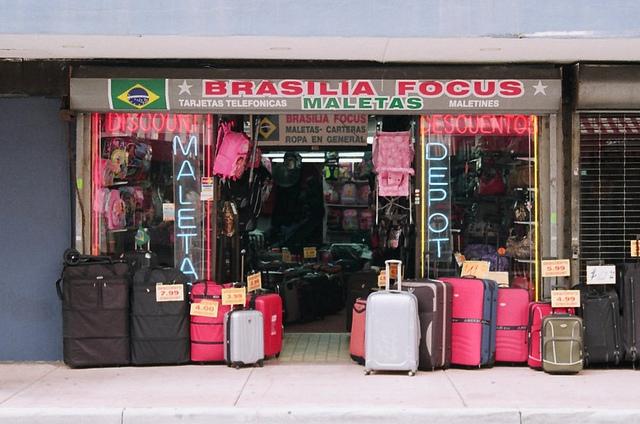What flag is on the store's sign?
Answer briefly. Brazil. What is in the photo?
Write a very short answer. Luggage. What words are in neon blue?
Keep it brief. Maleta depot. 